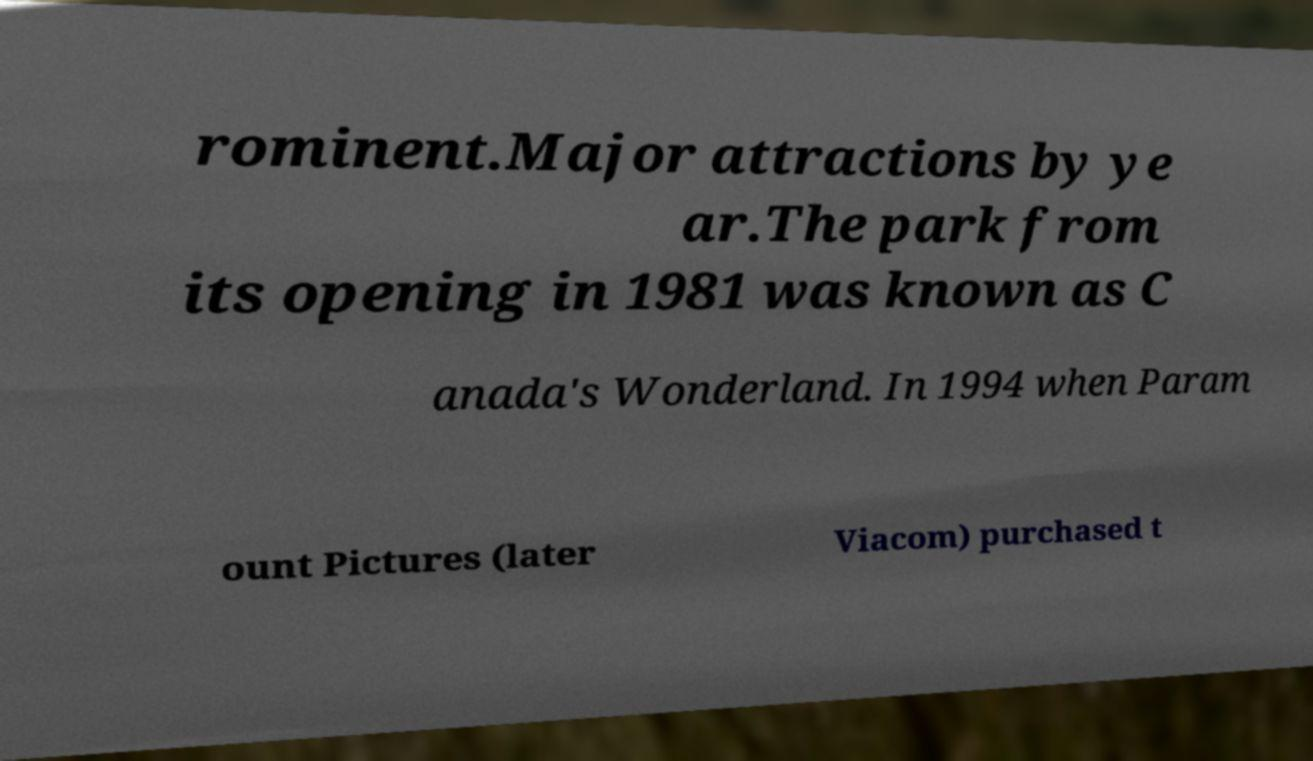I need the written content from this picture converted into text. Can you do that? rominent.Major attractions by ye ar.The park from its opening in 1981 was known as C anada's Wonderland. In 1994 when Param ount Pictures (later Viacom) purchased t 